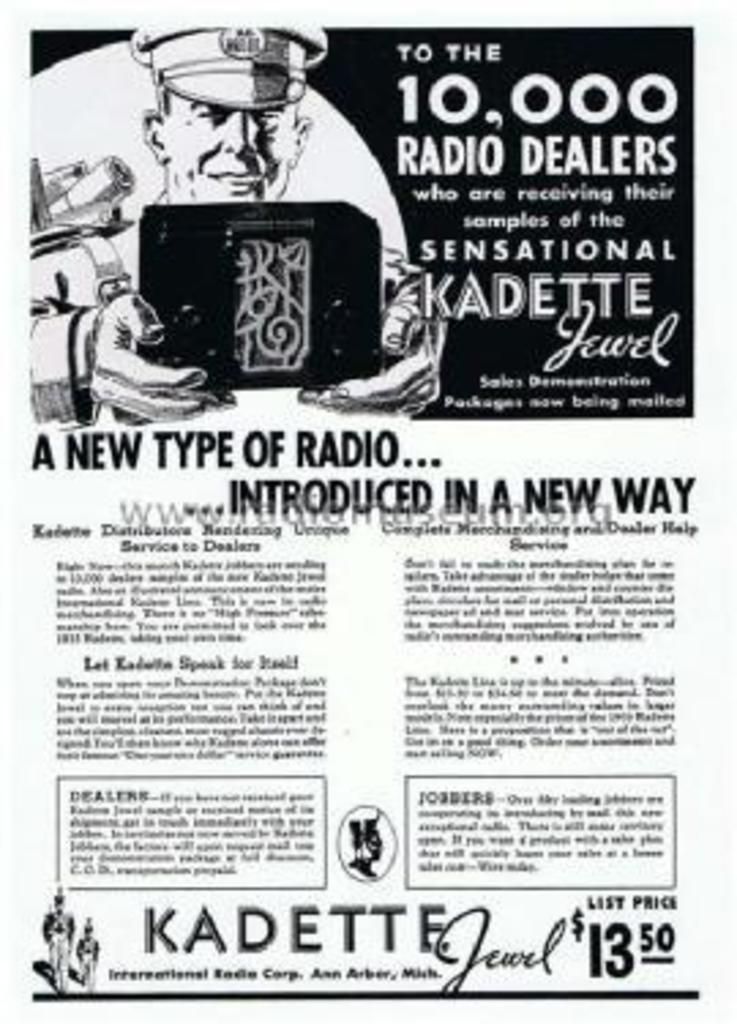<image>
Share a concise interpretation of the image provided. 10000 radio dealer will receive a sample of the radio 